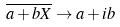<formula> <loc_0><loc_0><loc_500><loc_500>\overline { a + b X } \rightarrow a + i b</formula> 